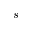<formula> <loc_0><loc_0><loc_500><loc_500>s</formula> 